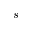<formula> <loc_0><loc_0><loc_500><loc_500>s</formula> 